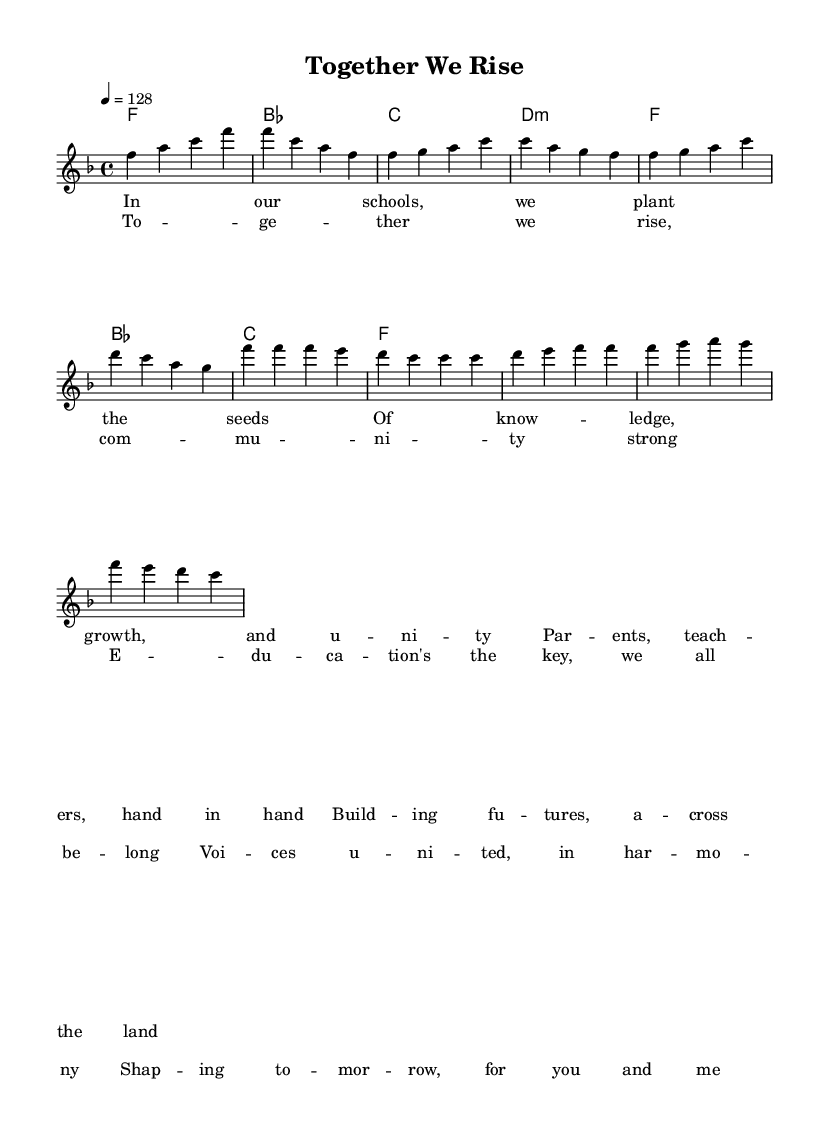What is the key signature of this music? The key signature is F major, indicated by one flat (B♭).
Answer: F major What is the time signature of this music? The time signature is four-four, which means there are four beats in a measure.
Answer: 4/4 What is the tempo marking of this piece? The tempo marking is 128 beats per minute, indicated at the start of the score.
Answer: 128 How many measures are in the chorus section? The chorus section consists of four measures, as counted from the provided notes.
Answer: 4 What are the primary themes suggested by the lyrics? The primary themes are community, education, and unity, as expressed through lyrics about collaboration and support.
Answer: Community, education, unity Which chords are used in the chorus? The chords in the chorus are F, C, and G, selected based on the chord progression shown.
Answer: F, C, G What type of music is represented by this piece? This piece represents uplifting house music, characterized by its upbeat tempo and motivational lyrics about community engagement.
Answer: Uplifting house 